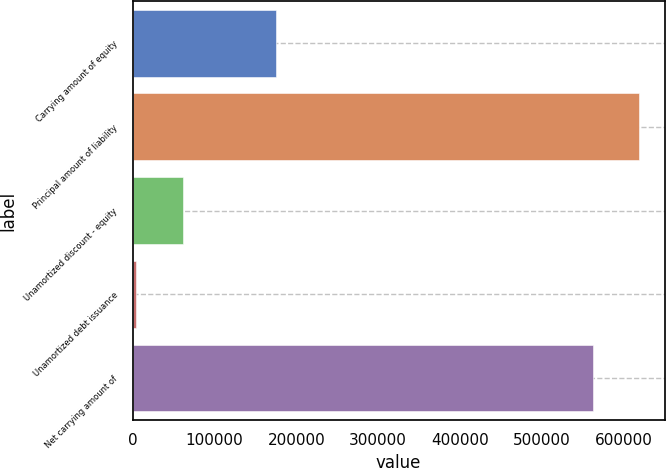Convert chart to OTSL. <chart><loc_0><loc_0><loc_500><loc_500><bar_chart><fcel>Carrying amount of equity<fcel>Principal amount of liability<fcel>Unamortized discount - equity<fcel>Unamortized debt issuance<fcel>Net carrying amount of<nl><fcel>175446<fcel>619453<fcel>61288.1<fcel>4209<fcel>562374<nl></chart> 